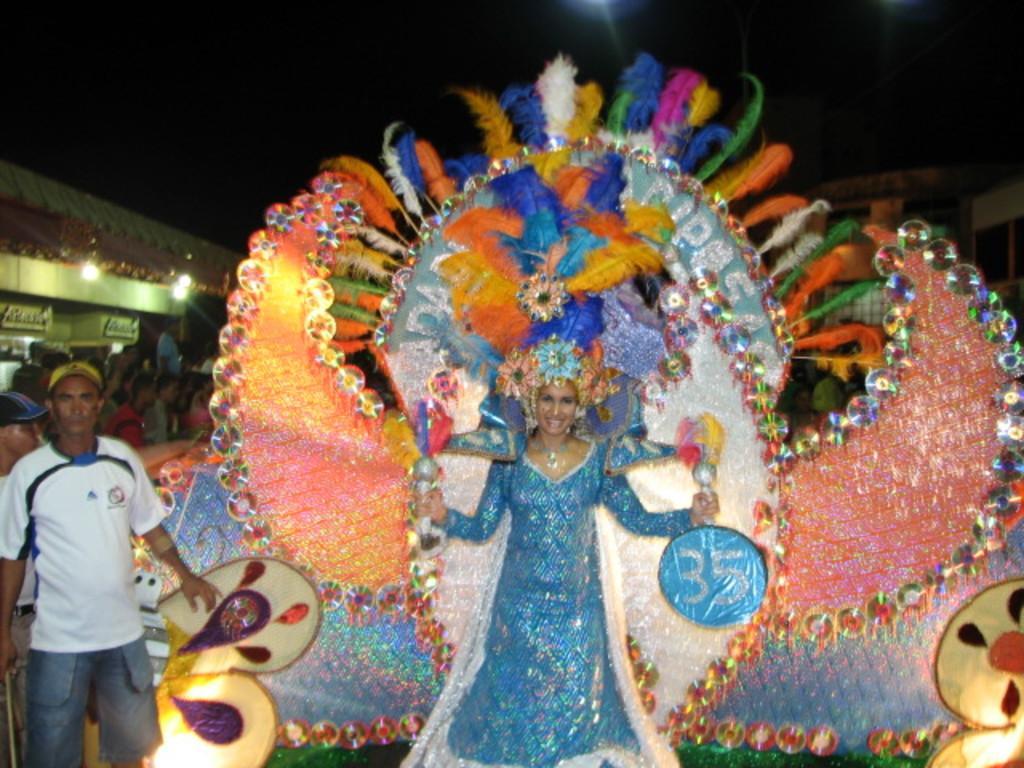How would you summarize this image in a sentence or two? In this image, we can see a woman standing and there are some people standing, we can see some lights. 